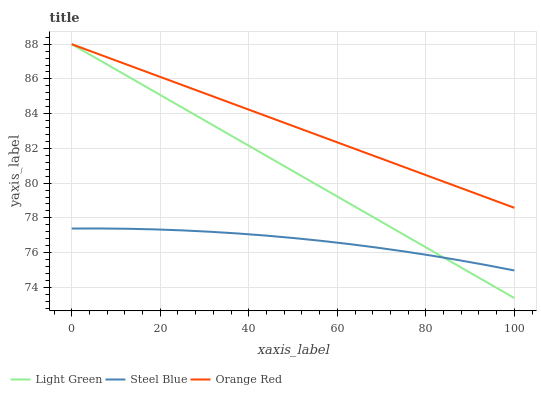Does Steel Blue have the minimum area under the curve?
Answer yes or no. Yes. Does Orange Red have the maximum area under the curve?
Answer yes or no. Yes. Does Light Green have the minimum area under the curve?
Answer yes or no. No. Does Light Green have the maximum area under the curve?
Answer yes or no. No. Is Light Green the smoothest?
Answer yes or no. Yes. Is Steel Blue the roughest?
Answer yes or no. Yes. Is Orange Red the smoothest?
Answer yes or no. No. Is Orange Red the roughest?
Answer yes or no. No. Does Light Green have the lowest value?
Answer yes or no. Yes. Does Orange Red have the lowest value?
Answer yes or no. No. Does Orange Red have the highest value?
Answer yes or no. Yes. Is Steel Blue less than Orange Red?
Answer yes or no. Yes. Is Orange Red greater than Steel Blue?
Answer yes or no. Yes. Does Light Green intersect Orange Red?
Answer yes or no. Yes. Is Light Green less than Orange Red?
Answer yes or no. No. Is Light Green greater than Orange Red?
Answer yes or no. No. Does Steel Blue intersect Orange Red?
Answer yes or no. No. 